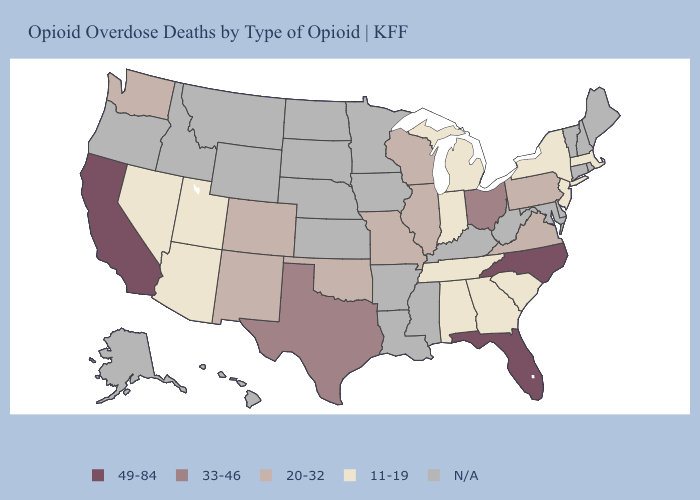What is the value of Oregon?
Short answer required. N/A. What is the highest value in the USA?
Keep it brief. 49-84. Which states have the lowest value in the West?
Answer briefly. Arizona, Nevada, Utah. Which states have the lowest value in the Northeast?
Give a very brief answer. Massachusetts, New Jersey, New York. What is the value of Vermont?
Answer briefly. N/A. What is the value of Hawaii?
Write a very short answer. N/A. What is the highest value in the South ?
Give a very brief answer. 49-84. Does the map have missing data?
Concise answer only. Yes. Is the legend a continuous bar?
Give a very brief answer. No. What is the value of Indiana?
Write a very short answer. 11-19. Name the states that have a value in the range 49-84?
Be succinct. California, Florida, North Carolina. Does Florida have the highest value in the South?
Concise answer only. Yes. Among the states that border Kentucky , does Indiana have the lowest value?
Give a very brief answer. Yes. 